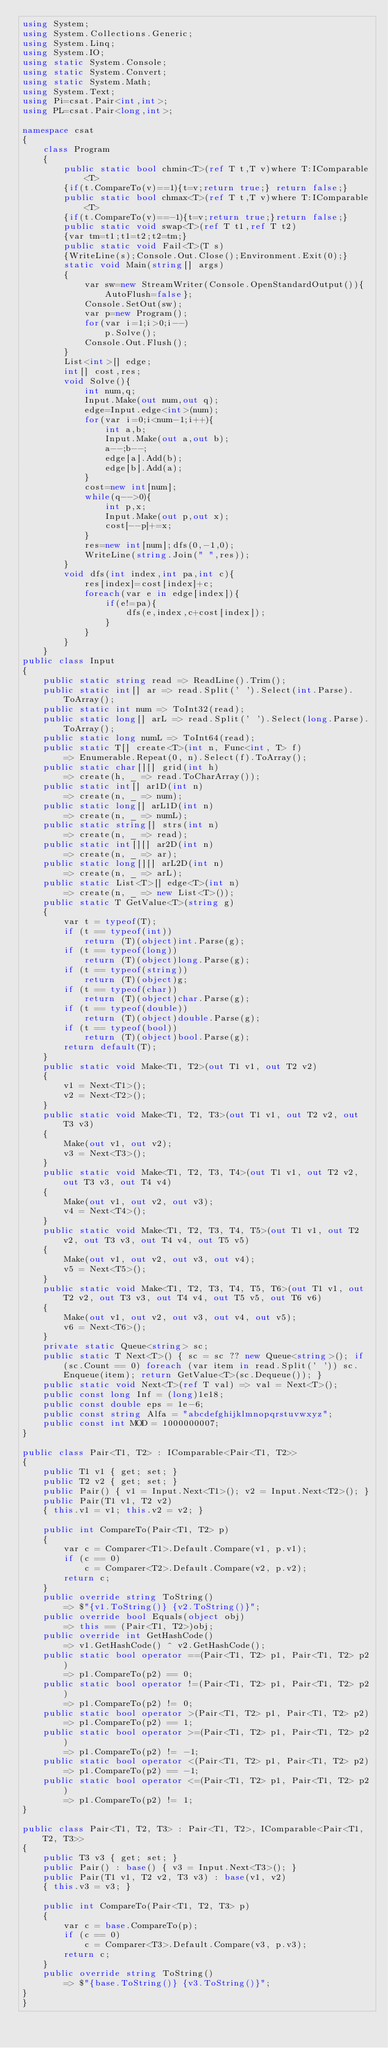Convert code to text. <code><loc_0><loc_0><loc_500><loc_500><_C#_>using System;
using System.Collections.Generic;
using System.Linq;
using System.IO;
using static System.Console;
using static System.Convert;
using static System.Math;
using System.Text;
using Pi=csat.Pair<int,int>;
using PL=csat.Pair<long,int>;

namespace csat
{
    class Program
    {
        public static bool chmin<T>(ref T t,T v)where T:IComparable<T>
        {if(t.CompareTo(v)==1){t=v;return true;} return false;}
        public static bool chmax<T>(ref T t,T v)where T:IComparable<T>
        {if(t.CompareTo(v)==-1){t=v;return true;}return false;}
        public static void swap<T>(ref T t1,ref T t2)
        {var tm=t1;t1=t2;t2=tm;}
        public static void Fail<T>(T s)
        {WriteLine(s);Console.Out.Close();Environment.Exit(0);}
        static void Main(string[] args)
        {
            var sw=new StreamWriter(Console.OpenStandardOutput()){AutoFlush=false};
            Console.SetOut(sw);
            var p=new Program();
            for(var i=1;i>0;i--)
                p.Solve();
            Console.Out.Flush();
        }
        List<int>[] edge;
        int[] cost,res;
        void Solve(){
            int num,q;
            Input.Make(out num,out q);
            edge=Input.edge<int>(num);
            for(var i=0;i<num-1;i++){
                int a,b;
                Input.Make(out a,out b);
                a--;b--;
                edge[a].Add(b);
                edge[b].Add(a);
            }
            cost=new int[num];
            while(q-->0){
                int p,x;
                Input.Make(out p,out x);
                cost[--p]+=x;
            }
            res=new int[num];dfs(0,-1,0);
            WriteLine(string.Join(" ",res));
        }
        void dfs(int index,int pa,int c){
            res[index]=cost[index]+c;
            foreach(var e in edge[index]){
                if(e!=pa){
                    dfs(e,index,c+cost[index]);
                }
            }
        }
    }
public class Input
{
    public static string read => ReadLine().Trim();
    public static int[] ar => read.Split(' ').Select(int.Parse).ToArray();
    public static int num => ToInt32(read);
    public static long[] arL => read.Split(' ').Select(long.Parse).ToArray();
    public static long numL => ToInt64(read);
    public static T[] create<T>(int n, Func<int, T> f)
        => Enumerable.Repeat(0, n).Select(f).ToArray();
    public static char[][] grid(int h)
        => create(h, _ => read.ToCharArray());
    public static int[] ar1D(int n)
        => create(n, _ => num);
    public static long[] arL1D(int n)
        => create(n, _ => numL);
    public static string[] strs(int n)
        => create(n, _ => read);
    public static int[][] ar2D(int n)
        => create(n, _ => ar);
    public static long[][] arL2D(int n)
        => create(n, _ => arL);
    public static List<T>[] edge<T>(int n)
        => create(n, _ => new List<T>());
    public static T GetValue<T>(string g)
    {
        var t = typeof(T);
        if (t == typeof(int))
            return (T)(object)int.Parse(g);
        if (t == typeof(long))
            return (T)(object)long.Parse(g);
        if (t == typeof(string))
            return (T)(object)g;
        if (t == typeof(char))
            return (T)(object)char.Parse(g);
        if (t == typeof(double))
            return (T)(object)double.Parse(g);
        if (t == typeof(bool))
            return (T)(object)bool.Parse(g);
        return default(T);
    }
    public static void Make<T1, T2>(out T1 v1, out T2 v2)
    {
        v1 = Next<T1>();
        v2 = Next<T2>();
    }
    public static void Make<T1, T2, T3>(out T1 v1, out T2 v2, out T3 v3)
    {
        Make(out v1, out v2);
        v3 = Next<T3>();
    }
    public static void Make<T1, T2, T3, T4>(out T1 v1, out T2 v2, out T3 v3, out T4 v4)
    {
        Make(out v1, out v2, out v3);
        v4 = Next<T4>();
    }
    public static void Make<T1, T2, T3, T4, T5>(out T1 v1, out T2 v2, out T3 v3, out T4 v4, out T5 v5)
    {
        Make(out v1, out v2, out v3, out v4);
        v5 = Next<T5>();
    }
    public static void Make<T1, T2, T3, T4, T5, T6>(out T1 v1, out T2 v2, out T3 v3, out T4 v4, out T5 v5, out T6 v6)
    {
        Make(out v1, out v2, out v3, out v4, out v5);
        v6 = Next<T6>();
    }
    private static Queue<string> sc;
    public static T Next<T>() { sc = sc ?? new Queue<string>(); if (sc.Count == 0) foreach (var item in read.Split(' ')) sc.Enqueue(item); return GetValue<T>(sc.Dequeue()); }
    public static void Next<T>(ref T val) => val = Next<T>();
    public const long Inf = (long)1e18;
    public const double eps = 1e-6;
    public const string Alfa = "abcdefghijklmnopqrstuvwxyz";
    public const int MOD = 1000000007;
}
 
public class Pair<T1, T2> : IComparable<Pair<T1, T2>>
{
    public T1 v1 { get; set; }
    public T2 v2 { get; set; }
    public Pair() { v1 = Input.Next<T1>(); v2 = Input.Next<T2>(); }
    public Pair(T1 v1, T2 v2)
    { this.v1 = v1; this.v2 = v2; }
 
    public int CompareTo(Pair<T1, T2> p)
    {
        var c = Comparer<T1>.Default.Compare(v1, p.v1);
        if (c == 0)
            c = Comparer<T2>.Default.Compare(v2, p.v2);
        return c;
    }
    public override string ToString()
        => $"{v1.ToString()} {v2.ToString()}";
    public override bool Equals(object obj)
        => this == (Pair<T1, T2>)obj;
    public override int GetHashCode()
        => v1.GetHashCode() ^ v2.GetHashCode();
    public static bool operator ==(Pair<T1, T2> p1, Pair<T1, T2> p2)
        => p1.CompareTo(p2) == 0;
    public static bool operator !=(Pair<T1, T2> p1, Pair<T1, T2> p2)
        => p1.CompareTo(p2) != 0;
    public static bool operator >(Pair<T1, T2> p1, Pair<T1, T2> p2)
        => p1.CompareTo(p2) == 1;
    public static bool operator >=(Pair<T1, T2> p1, Pair<T1, T2> p2)
        => p1.CompareTo(p2) != -1;
    public static bool operator <(Pair<T1, T2> p1, Pair<T1, T2> p2)
        => p1.CompareTo(p2) == -1;
    public static bool operator <=(Pair<T1, T2> p1, Pair<T1, T2> p2)
        => p1.CompareTo(p2) != 1;
}
 
public class Pair<T1, T2, T3> : Pair<T1, T2>, IComparable<Pair<T1, T2, T3>>
{
    public T3 v3 { get; set; }
    public Pair() : base() { v3 = Input.Next<T3>(); }
    public Pair(T1 v1, T2 v2, T3 v3) : base(v1, v2)
    { this.v3 = v3; }
 
    public int CompareTo(Pair<T1, T2, T3> p)
    {
        var c = base.CompareTo(p);
        if (c == 0)
            c = Comparer<T3>.Default.Compare(v3, p.v3);
        return c;
    }
    public override string ToString()
        => $"{base.ToString()} {v3.ToString()}";
}
}
</code> 